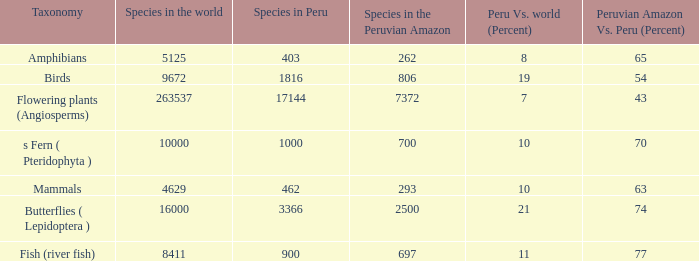What's the species in the world with peruvian amazon vs. peru (percent)  of 63 4629.0. 